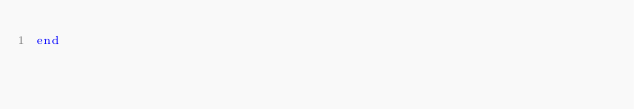Convert code to text. <code><loc_0><loc_0><loc_500><loc_500><_Ruby_>end
</code> 